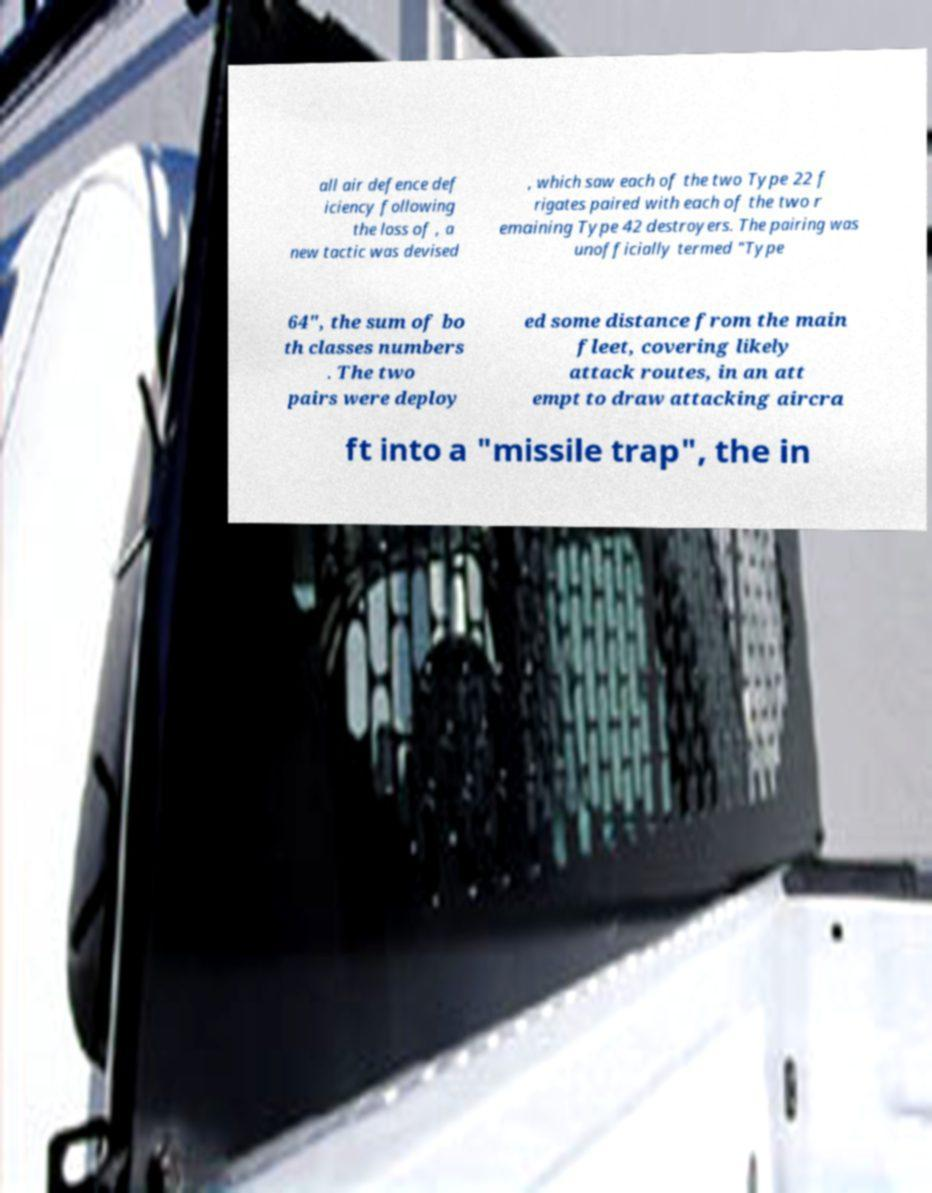Please read and relay the text visible in this image. What does it say? all air defence def iciency following the loss of , a new tactic was devised , which saw each of the two Type 22 f rigates paired with each of the two r emaining Type 42 destroyers. The pairing was unofficially termed "Type 64", the sum of bo th classes numbers . The two pairs were deploy ed some distance from the main fleet, covering likely attack routes, in an att empt to draw attacking aircra ft into a "missile trap", the in 